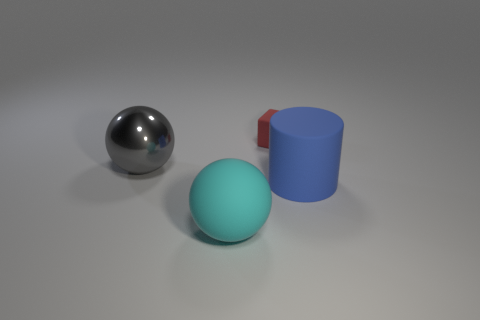Is there any other thing that is the same size as the red block?
Your answer should be very brief. No. Are there more balls in front of the metal thing than small blue balls?
Provide a short and direct response. Yes. What number of large objects are either purple shiny cubes or things?
Your answer should be compact. 3. What number of cyan rubber objects have the same shape as the big gray shiny object?
Keep it short and to the point. 1. There is a object to the left of the matte thing left of the red rubber cube; what is it made of?
Keep it short and to the point. Metal. How big is the ball that is right of the large gray metallic sphere?
Provide a short and direct response. Large. How many green things are either small matte objects or large rubber balls?
Provide a short and direct response. 0. Is there any other thing that is made of the same material as the big gray object?
Provide a succinct answer. No. There is another large thing that is the same shape as the cyan thing; what is it made of?
Provide a short and direct response. Metal. Are there an equal number of big cyan matte spheres that are on the right side of the big rubber ball and small blue spheres?
Keep it short and to the point. Yes. 